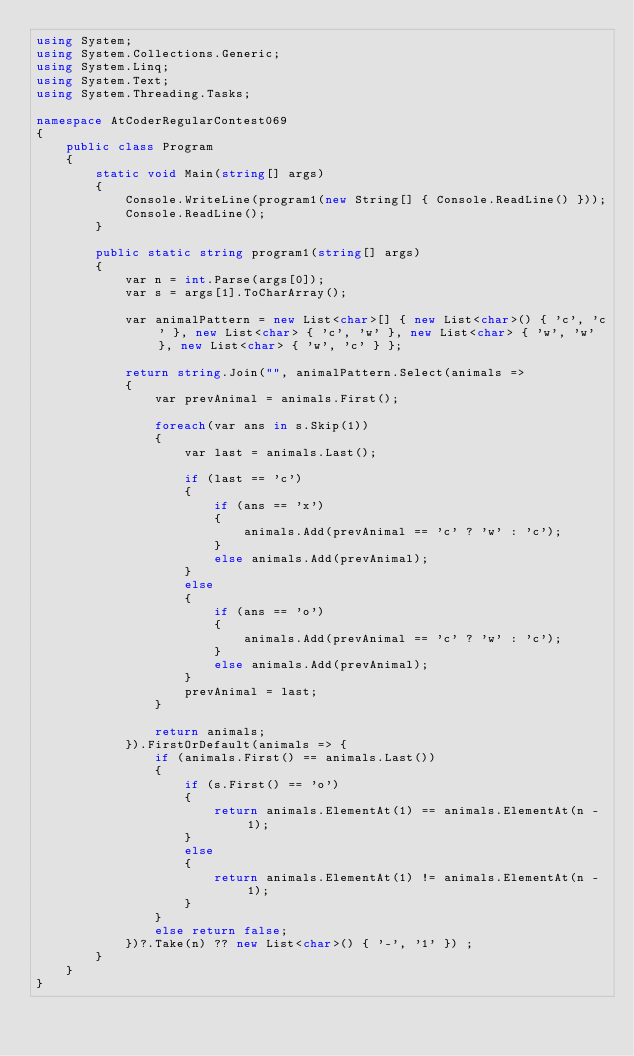<code> <loc_0><loc_0><loc_500><loc_500><_C#_>using System;
using System.Collections.Generic;
using System.Linq;
using System.Text;
using System.Threading.Tasks;

namespace AtCoderRegularContest069
{
    public class Program
    {
        static void Main(string[] args)
        {
            Console.WriteLine(program1(new String[] { Console.ReadLine() }));
            Console.ReadLine();
        }

        public static string program1(string[] args)
        {
            var n = int.Parse(args[0]);
            var s = args[1].ToCharArray();

            var animalPattern = new List<char>[] { new List<char>() { 'c', 'c' }, new List<char> { 'c', 'w' }, new List<char> { 'w', 'w' }, new List<char> { 'w', 'c' } };

            return string.Join("", animalPattern.Select(animals =>
            {
                var prevAnimal = animals.First();
                             
                foreach(var ans in s.Skip(1))
                {
                    var last = animals.Last();

                    if (last == 'c')
                    {
                        if (ans == 'x')
                        {
                            animals.Add(prevAnimal == 'c' ? 'w' : 'c');
                        }
                        else animals.Add(prevAnimal);
                    }
                    else
                    {
                        if (ans == 'o')
                        {
                            animals.Add(prevAnimal == 'c' ? 'w' : 'c');
                        }
                        else animals.Add(prevAnimal);
                    }
                    prevAnimal = last;
                }

                return animals;
            }).FirstOrDefault(animals => {
                if (animals.First() == animals.Last())
                {
                    if (s.First() == 'o')
                    {
                        return animals.ElementAt(1) == animals.ElementAt(n - 1);
                    }
                    else
                    {
                        return animals.ElementAt(1) != animals.ElementAt(n - 1);
                    }
                }
                else return false;
            })?.Take(n) ?? new List<char>() { '-', '1' }) ;
        }
    }
}
</code> 